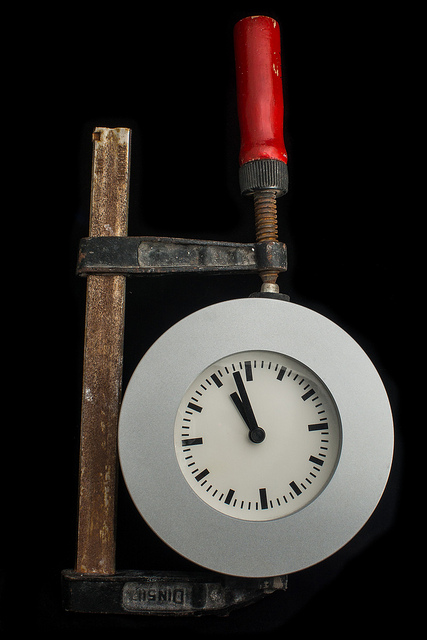Read all the text in this image. HSNIO 